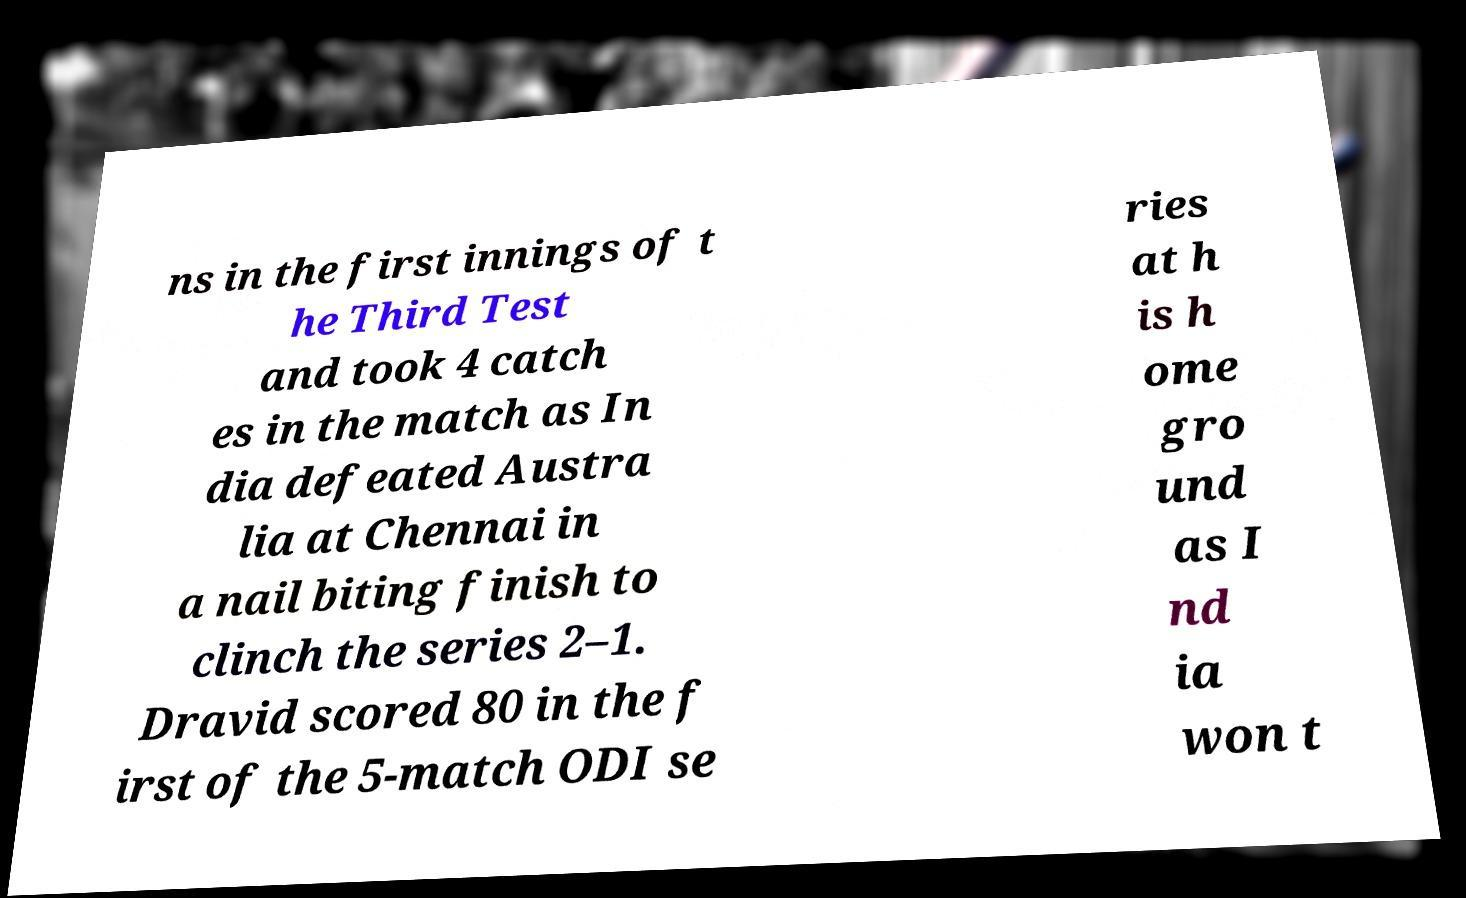There's text embedded in this image that I need extracted. Can you transcribe it verbatim? ns in the first innings of t he Third Test and took 4 catch es in the match as In dia defeated Austra lia at Chennai in a nail biting finish to clinch the series 2–1. Dravid scored 80 in the f irst of the 5-match ODI se ries at h is h ome gro und as I nd ia won t 